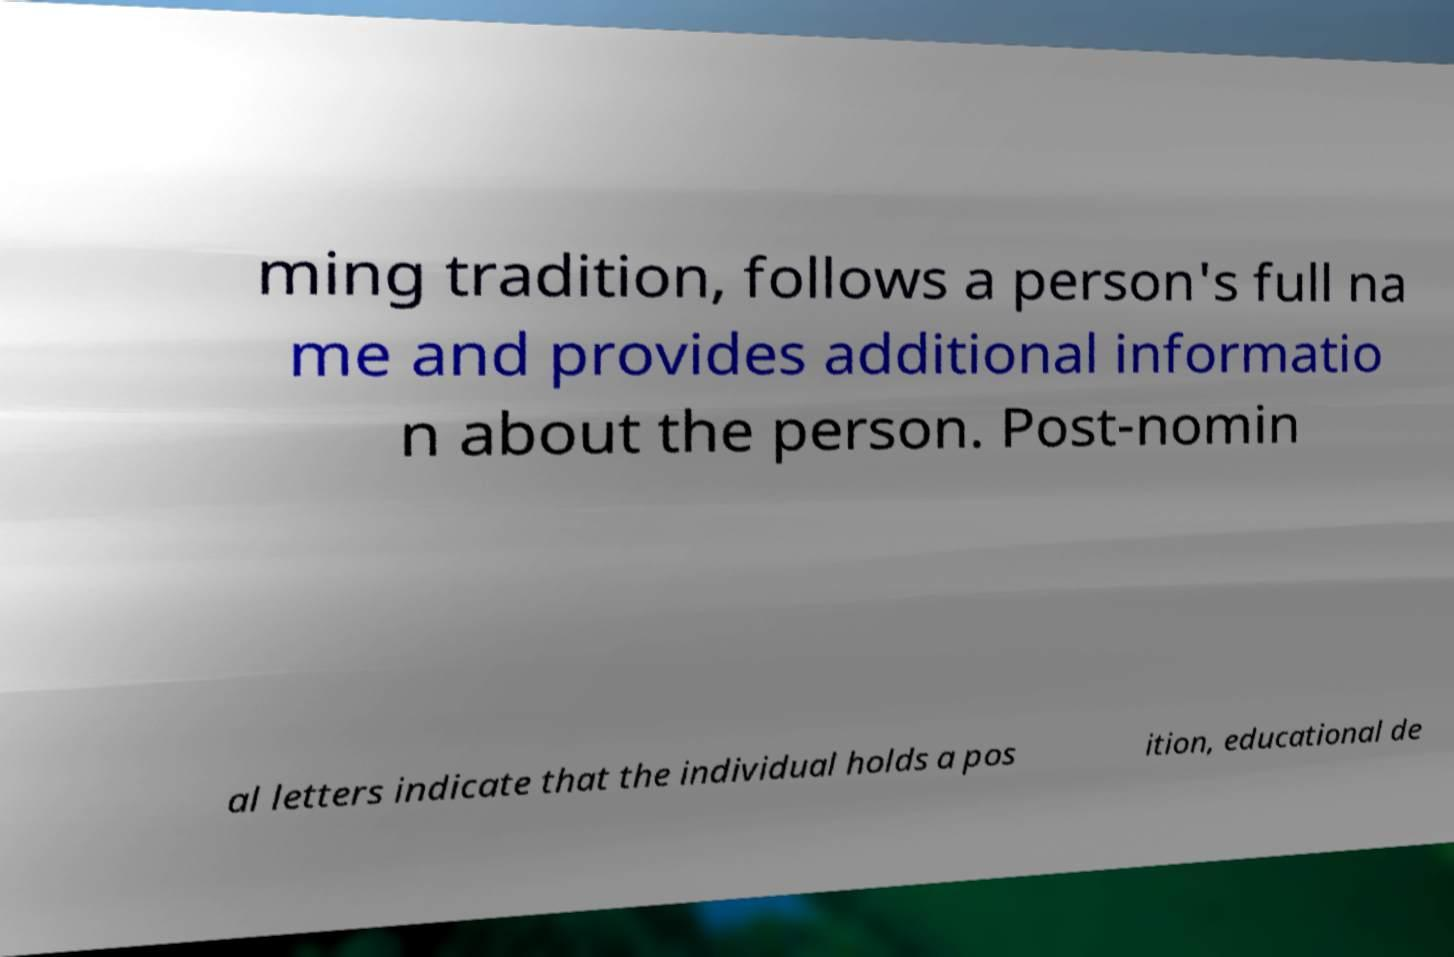Can you accurately transcribe the text from the provided image for me? ming tradition, follows a person's full na me and provides additional informatio n about the person. Post-nomin al letters indicate that the individual holds a pos ition, educational de 